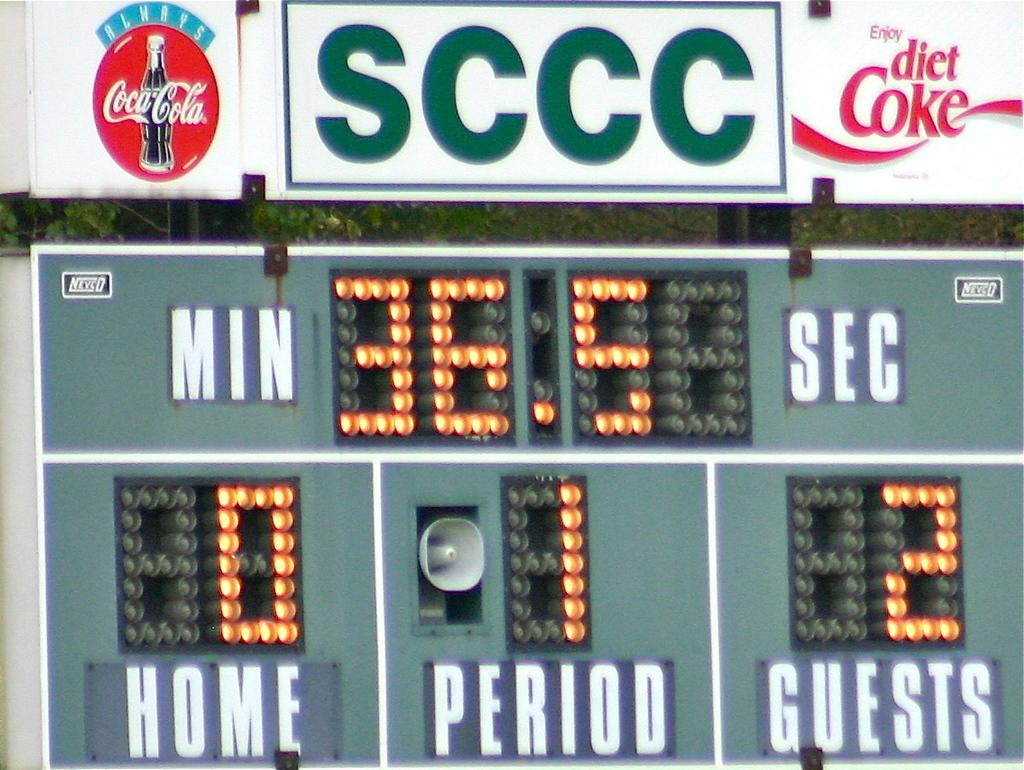<image>
Describe the image concisely. A scoreboard depicting the score of the guests having 2 points, and the home team having none. 